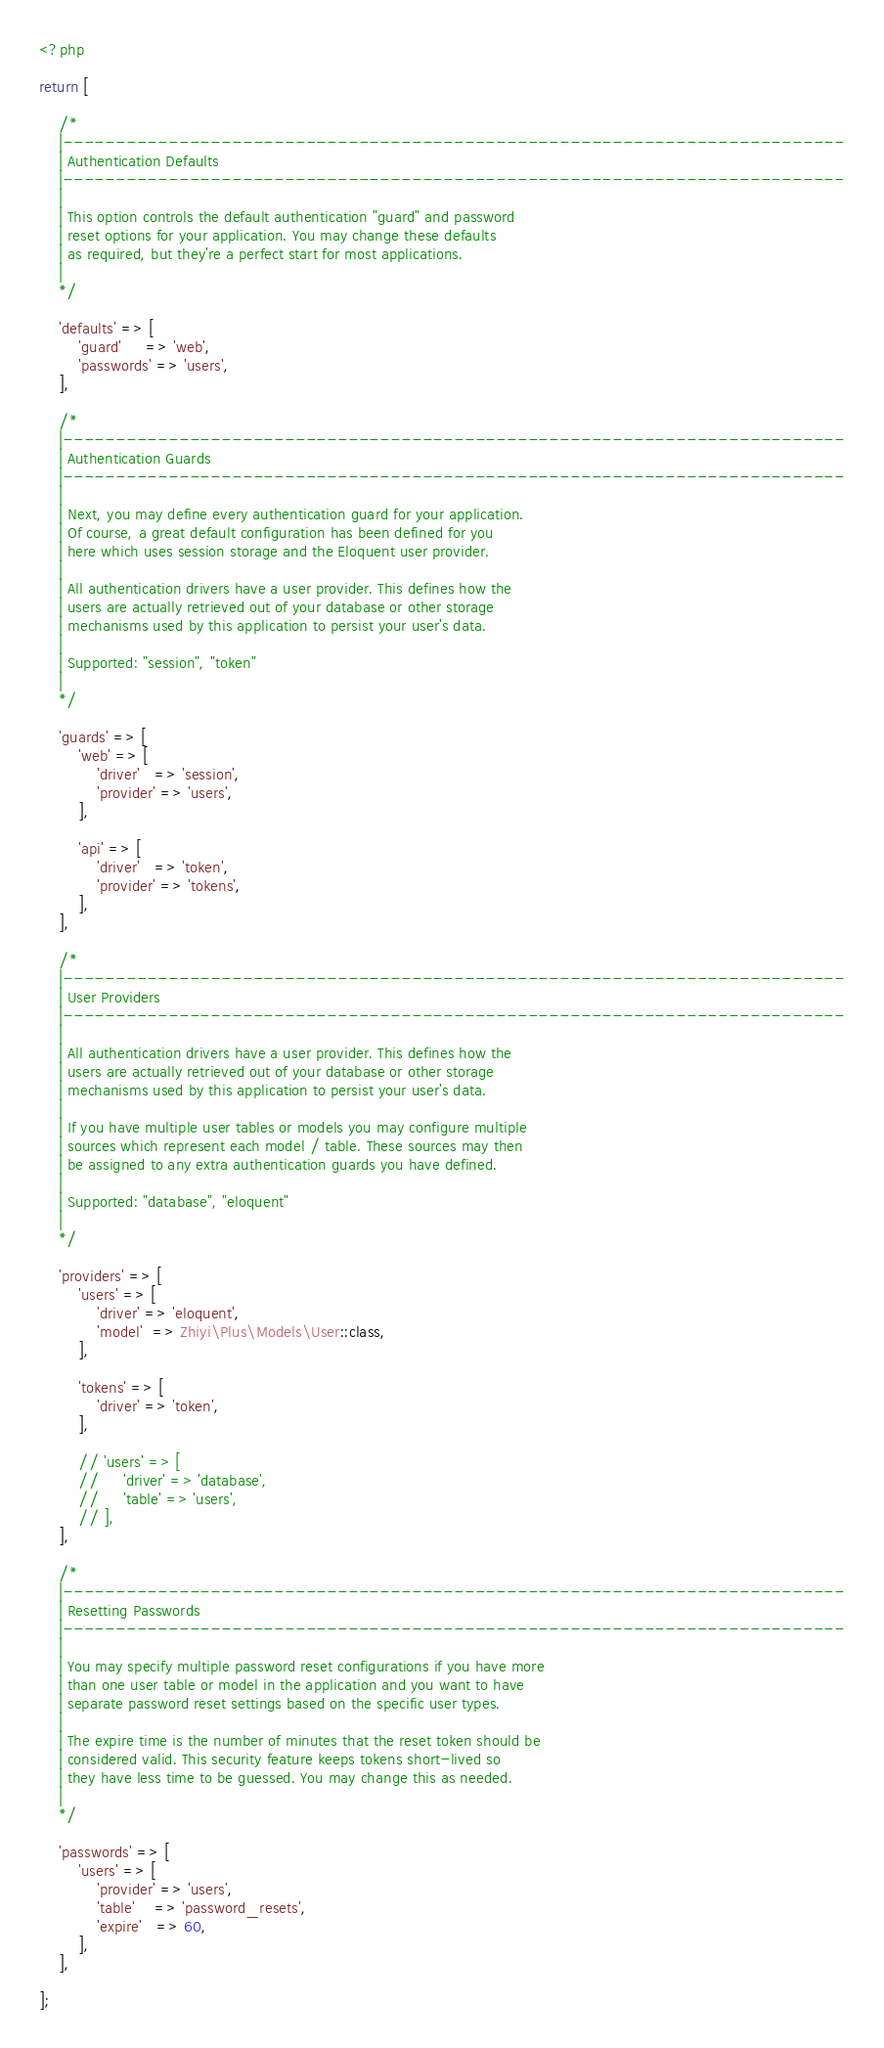Convert code to text. <code><loc_0><loc_0><loc_500><loc_500><_PHP_><?php

return [

    /*
    |--------------------------------------------------------------------------
    | Authentication Defaults
    |--------------------------------------------------------------------------
    |
    | This option controls the default authentication "guard" and password
    | reset options for your application. You may change these defaults
    | as required, but they're a perfect start for most applications.
    |
    */

    'defaults' => [
        'guard'     => 'web',
        'passwords' => 'users',
    ],

    /*
    |--------------------------------------------------------------------------
    | Authentication Guards
    |--------------------------------------------------------------------------
    |
    | Next, you may define every authentication guard for your application.
    | Of course, a great default configuration has been defined for you
    | here which uses session storage and the Eloquent user provider.
    |
    | All authentication drivers have a user provider. This defines how the
    | users are actually retrieved out of your database or other storage
    | mechanisms used by this application to persist your user's data.
    |
    | Supported: "session", "token"
    |
    */

    'guards' => [
        'web' => [
            'driver'   => 'session',
            'provider' => 'users',
        ],

        'api' => [
            'driver'   => 'token',
            'provider' => 'tokens',
        ],
    ],

    /*
    |--------------------------------------------------------------------------
    | User Providers
    |--------------------------------------------------------------------------
    |
    | All authentication drivers have a user provider. This defines how the
    | users are actually retrieved out of your database or other storage
    | mechanisms used by this application to persist your user's data.
    |
    | If you have multiple user tables or models you may configure multiple
    | sources which represent each model / table. These sources may then
    | be assigned to any extra authentication guards you have defined.
    |
    | Supported: "database", "eloquent"
    |
    */

    'providers' => [
        'users' => [
            'driver' => 'eloquent',
            'model'  => Zhiyi\Plus\Models\User::class,
        ],

        'tokens' => [
            'driver' => 'token',
        ],

        // 'users' => [
        //     'driver' => 'database',
        //     'table' => 'users',
        // ],
    ],

    /*
    |--------------------------------------------------------------------------
    | Resetting Passwords
    |--------------------------------------------------------------------------
    |
    | You may specify multiple password reset configurations if you have more
    | than one user table or model in the application and you want to have
    | separate password reset settings based on the specific user types.
    |
    | The expire time is the number of minutes that the reset token should be
    | considered valid. This security feature keeps tokens short-lived so
    | they have less time to be guessed. You may change this as needed.
    |
    */

    'passwords' => [
        'users' => [
            'provider' => 'users',
            'table'    => 'password_resets',
            'expire'   => 60,
        ],
    ],

];
</code> 